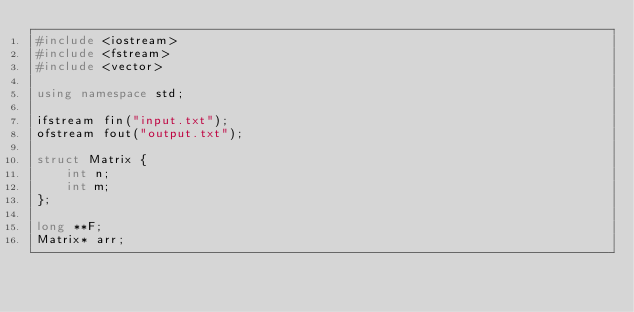Convert code to text. <code><loc_0><loc_0><loc_500><loc_500><_C++_>#include <iostream>
#include <fstream>
#include <vector>

using namespace std;

ifstream fin("input.txt");
ofstream fout("output.txt");

struct Matrix {
    int n;
    int m;
};

long **F;
Matrix* arr;
</code> 